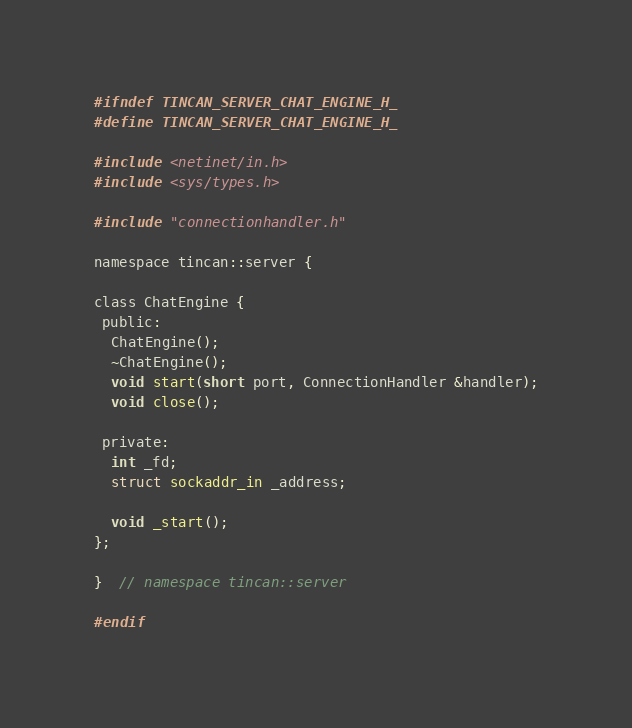<code> <loc_0><loc_0><loc_500><loc_500><_C_>#ifndef TINCAN_SERVER_CHAT_ENGINE_H_
#define TINCAN_SERVER_CHAT_ENGINE_H_

#include <netinet/in.h>
#include <sys/types.h>

#include "connectionhandler.h"

namespace tincan::server {

class ChatEngine {
 public:
  ChatEngine();
  ~ChatEngine();
  void start(short port, ConnectionHandler &handler);
  void close();

 private:
  int _fd;
  struct sockaddr_in _address;

  void _start();
};

}  // namespace tincan::server

#endif</code> 